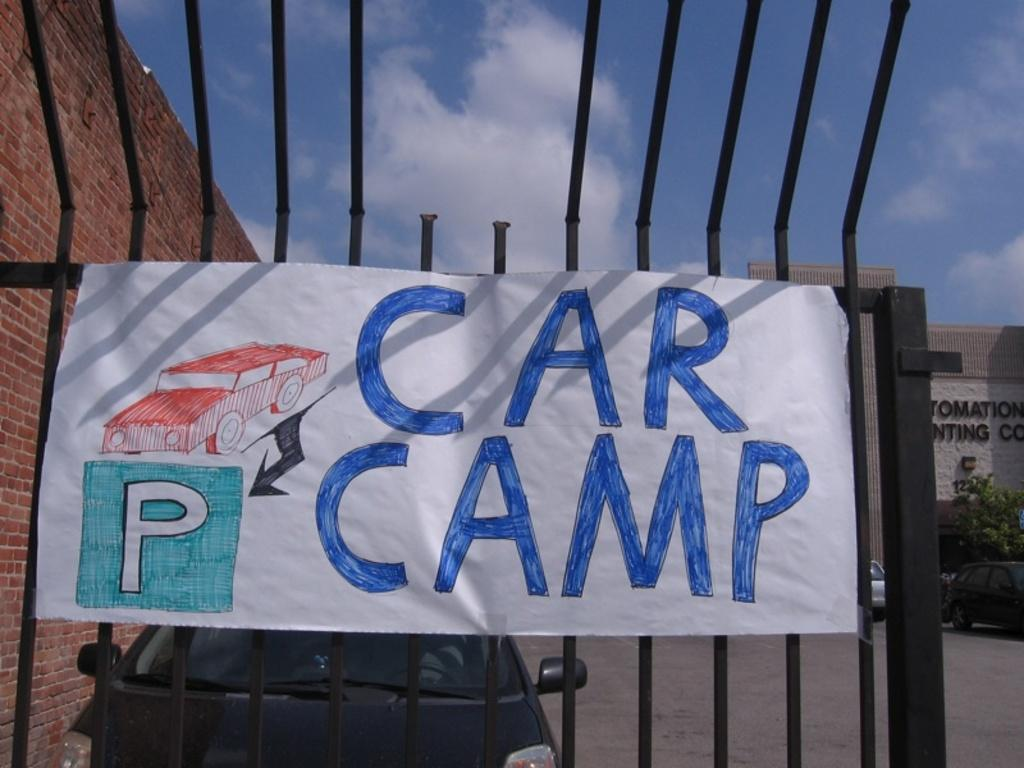What can be seen in the sky in the image? The sky with clouds is visible in the image. What type of structure is present in the image? There is a wall and a building in the image. Is there any vegetation in the image? Yes, a plant is present in the image. What is happening on the road in the image? Motor vehicles are on the road in the image. Can you describe any additional features on the building? There is a sign board attached to the grills in the image. What type of lawyer is depicted on the plant in the image? There is no lawyer depicted in the image, as it features a plant and other elements unrelated to a legal profession. 